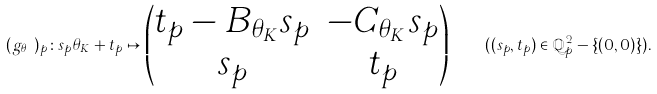<formula> <loc_0><loc_0><loc_500><loc_500>( g _ { \theta _ { K } } ) _ { p } \colon s _ { p } \theta _ { K } + t _ { p } \mapsto \begin{pmatrix} t _ { p } - B _ { \theta _ { K } } s _ { p } & - C _ { \theta _ { K } } s _ { p } \\ s _ { p } & t _ { p } \end{pmatrix} \quad ( ( s _ { p } , t _ { p } ) \in \mathbb { Q } _ { p } ^ { 2 } - \{ ( 0 , 0 ) \} ) .</formula> 